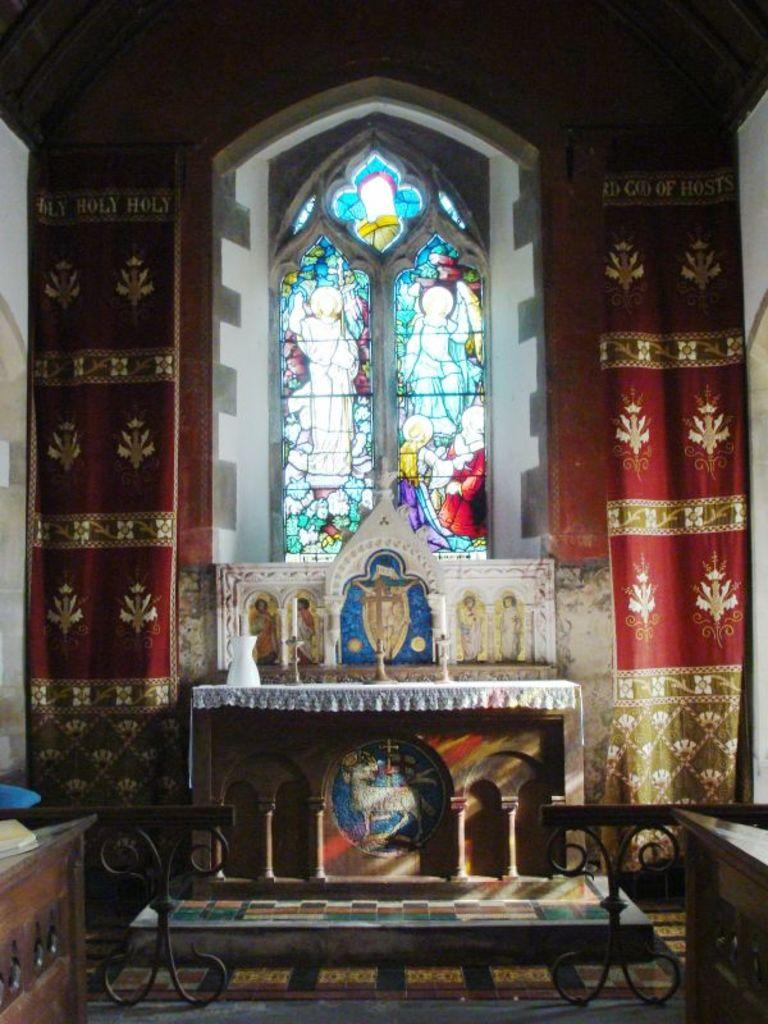What type of furniture is on the floor in the image? There are tables on the floor in the image. What is used to hold candles in the image? There are candle stands in the image. What type of window treatment is present in the image? There are curtains in the image. What allows natural light to enter the room in the image? There are windows in the image. What can be seen on the tables and candle stands in the image? There are objects visible in the image. What is visible behind the tables and candle stands in the image? There is a wall in the background of the image. How does the string move around in the image? There is no string present in the image. What is located at the top of the wall in the image? The image does not show any objects or features at the top of the wall. 